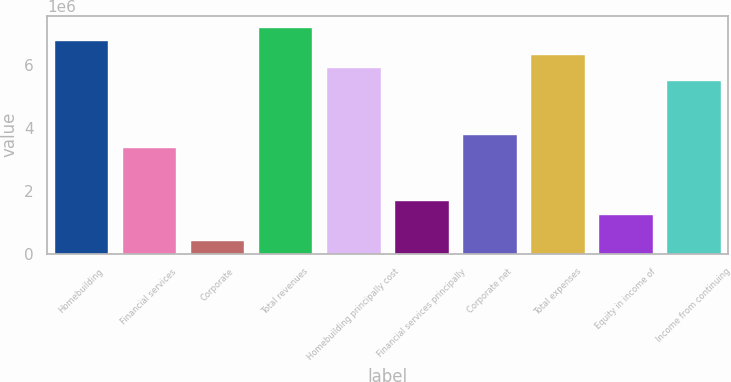Convert chart to OTSL. <chart><loc_0><loc_0><loc_500><loc_500><bar_chart><fcel>Homebuilding<fcel>Financial services<fcel>Corporate<fcel>Total revenues<fcel>Homebuilding principally cost<fcel>Financial services principally<fcel>Corporate net<fcel>Total expenses<fcel>Equity in income of<fcel>Income from continuing<nl><fcel>6.79e+06<fcel>3.395e+06<fcel>424375<fcel>7.21438e+06<fcel>5.94125e+06<fcel>1.6975e+06<fcel>3.81938e+06<fcel>6.36563e+06<fcel>1.27313e+06<fcel>5.51688e+06<nl></chart> 